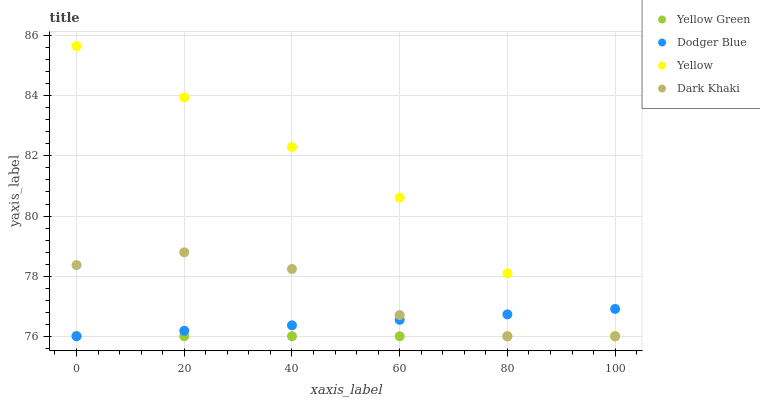Does Yellow Green have the minimum area under the curve?
Answer yes or no. Yes. Does Yellow have the maximum area under the curve?
Answer yes or no. Yes. Does Dodger Blue have the minimum area under the curve?
Answer yes or no. No. Does Dodger Blue have the maximum area under the curve?
Answer yes or no. No. Is Dodger Blue the smoothest?
Answer yes or no. Yes. Is Dark Khaki the roughest?
Answer yes or no. Yes. Is Yellow Green the smoothest?
Answer yes or no. No. Is Yellow Green the roughest?
Answer yes or no. No. Does Dark Khaki have the lowest value?
Answer yes or no. Yes. Does Yellow have the highest value?
Answer yes or no. Yes. Does Dodger Blue have the highest value?
Answer yes or no. No. Does Dark Khaki intersect Yellow Green?
Answer yes or no. Yes. Is Dark Khaki less than Yellow Green?
Answer yes or no. No. Is Dark Khaki greater than Yellow Green?
Answer yes or no. No. 